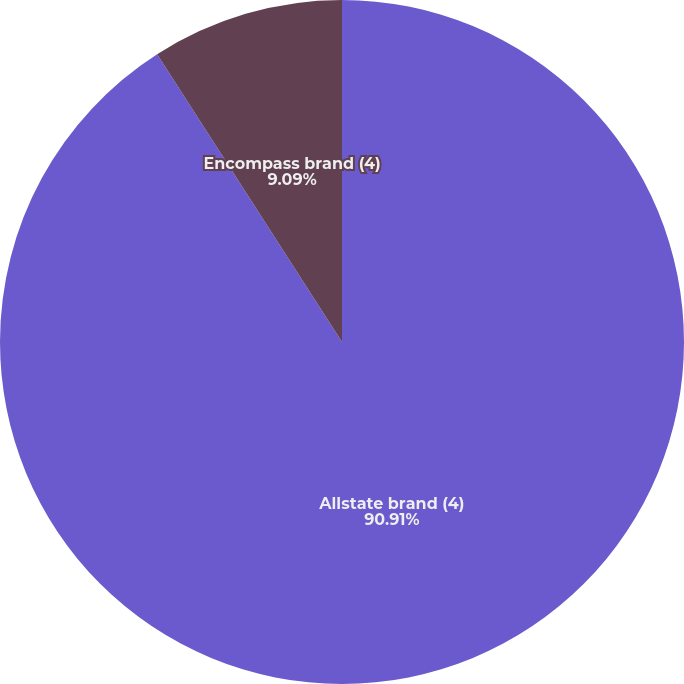Convert chart to OTSL. <chart><loc_0><loc_0><loc_500><loc_500><pie_chart><fcel>Allstate brand (4)<fcel>Encompass brand (4)<nl><fcel>90.91%<fcel>9.09%<nl></chart> 